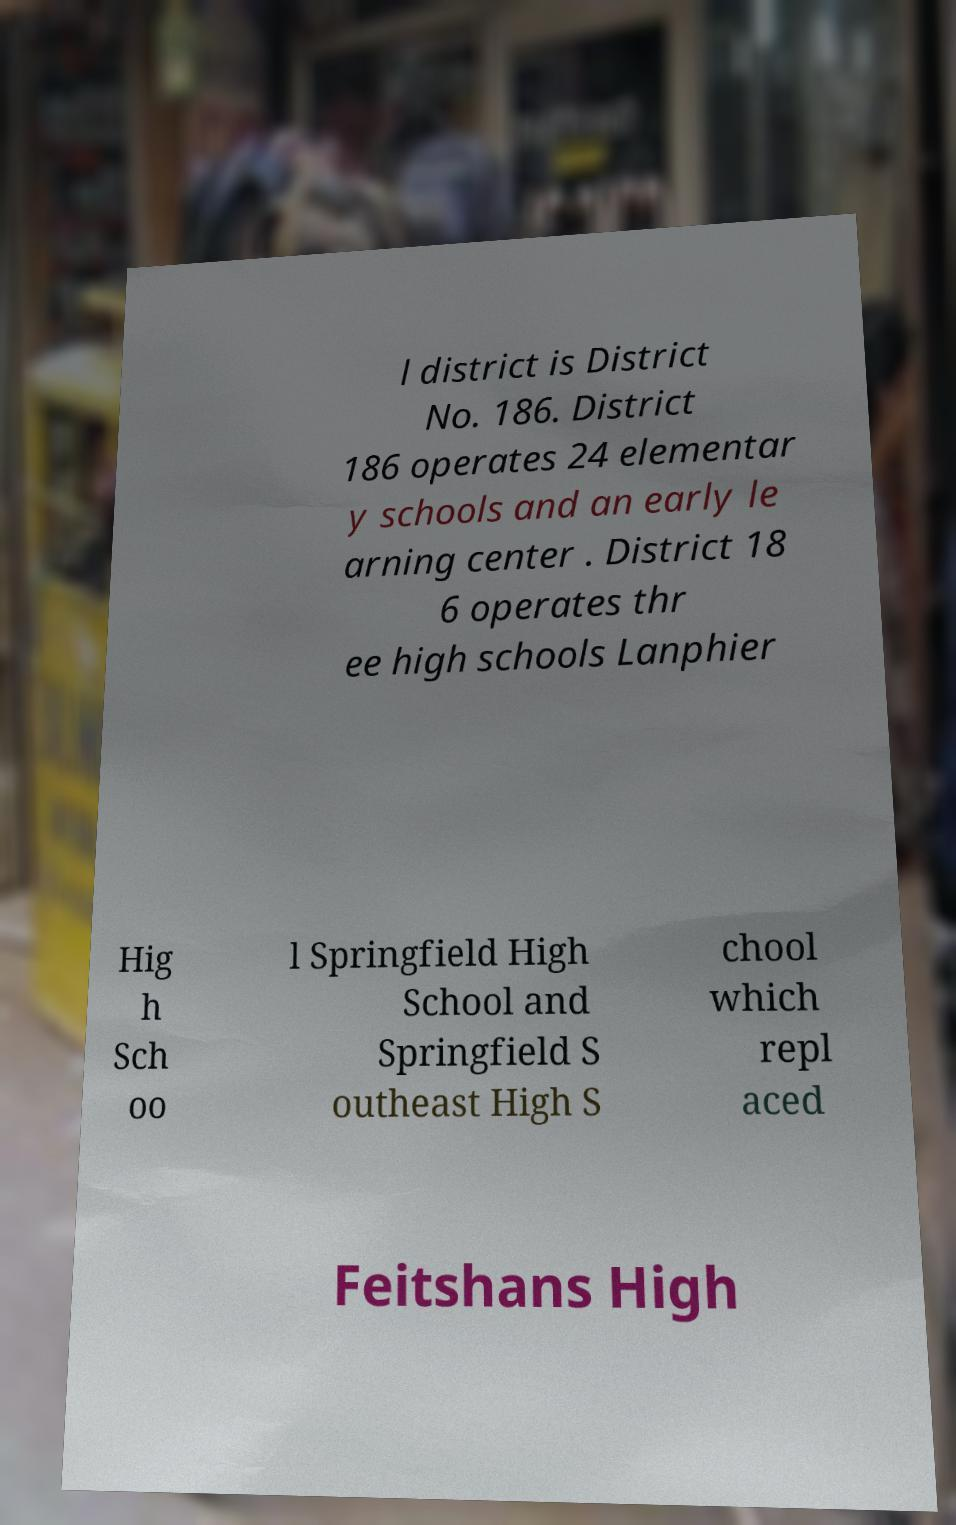Could you extract and type out the text from this image? l district is District No. 186. District 186 operates 24 elementar y schools and an early le arning center . District 18 6 operates thr ee high schools Lanphier Hig h Sch oo l Springfield High School and Springfield S outheast High S chool which repl aced Feitshans High 